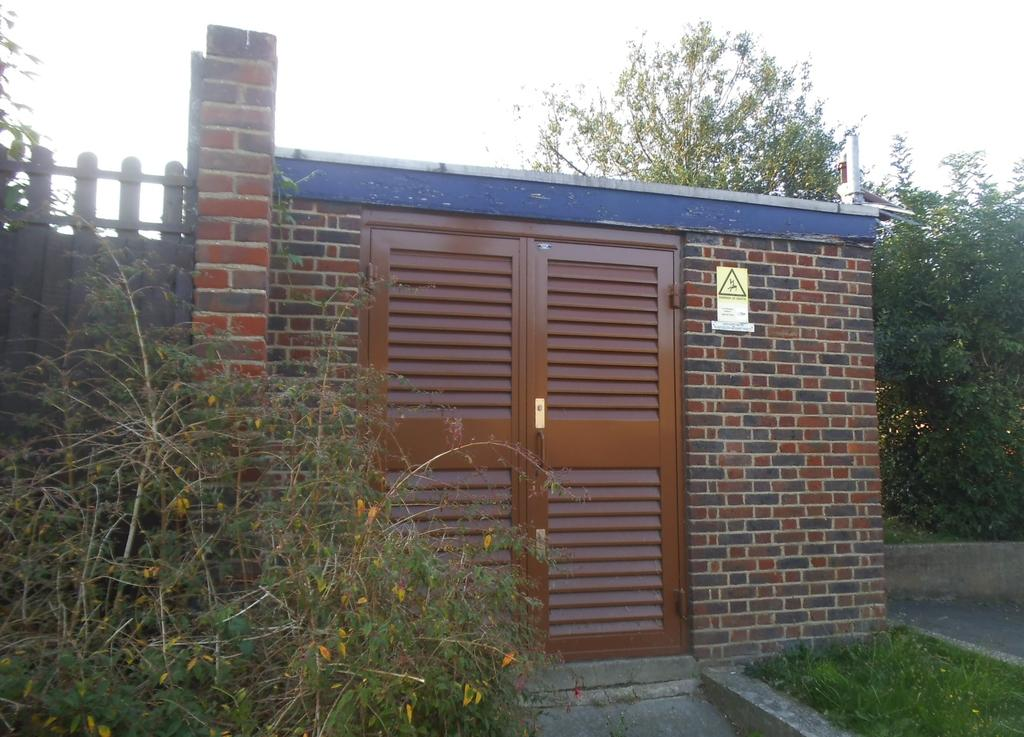What type of structure can be seen in the image? There is a wall in the image. What color are the doors on the wall? The doors in the image are brown-colored. What objects are made of wood in the image? There are boards in the image. What type of vegetation is visible in the image? There are trees and grass visible in the image. What is written on the boards in the image? Words are written on the boards in the image. What type of sack is hanging from the tree in the image? There is no sack hanging from the tree in the image. What type of club can be seen being used by the person in the image? There is no person or club present in the image. 